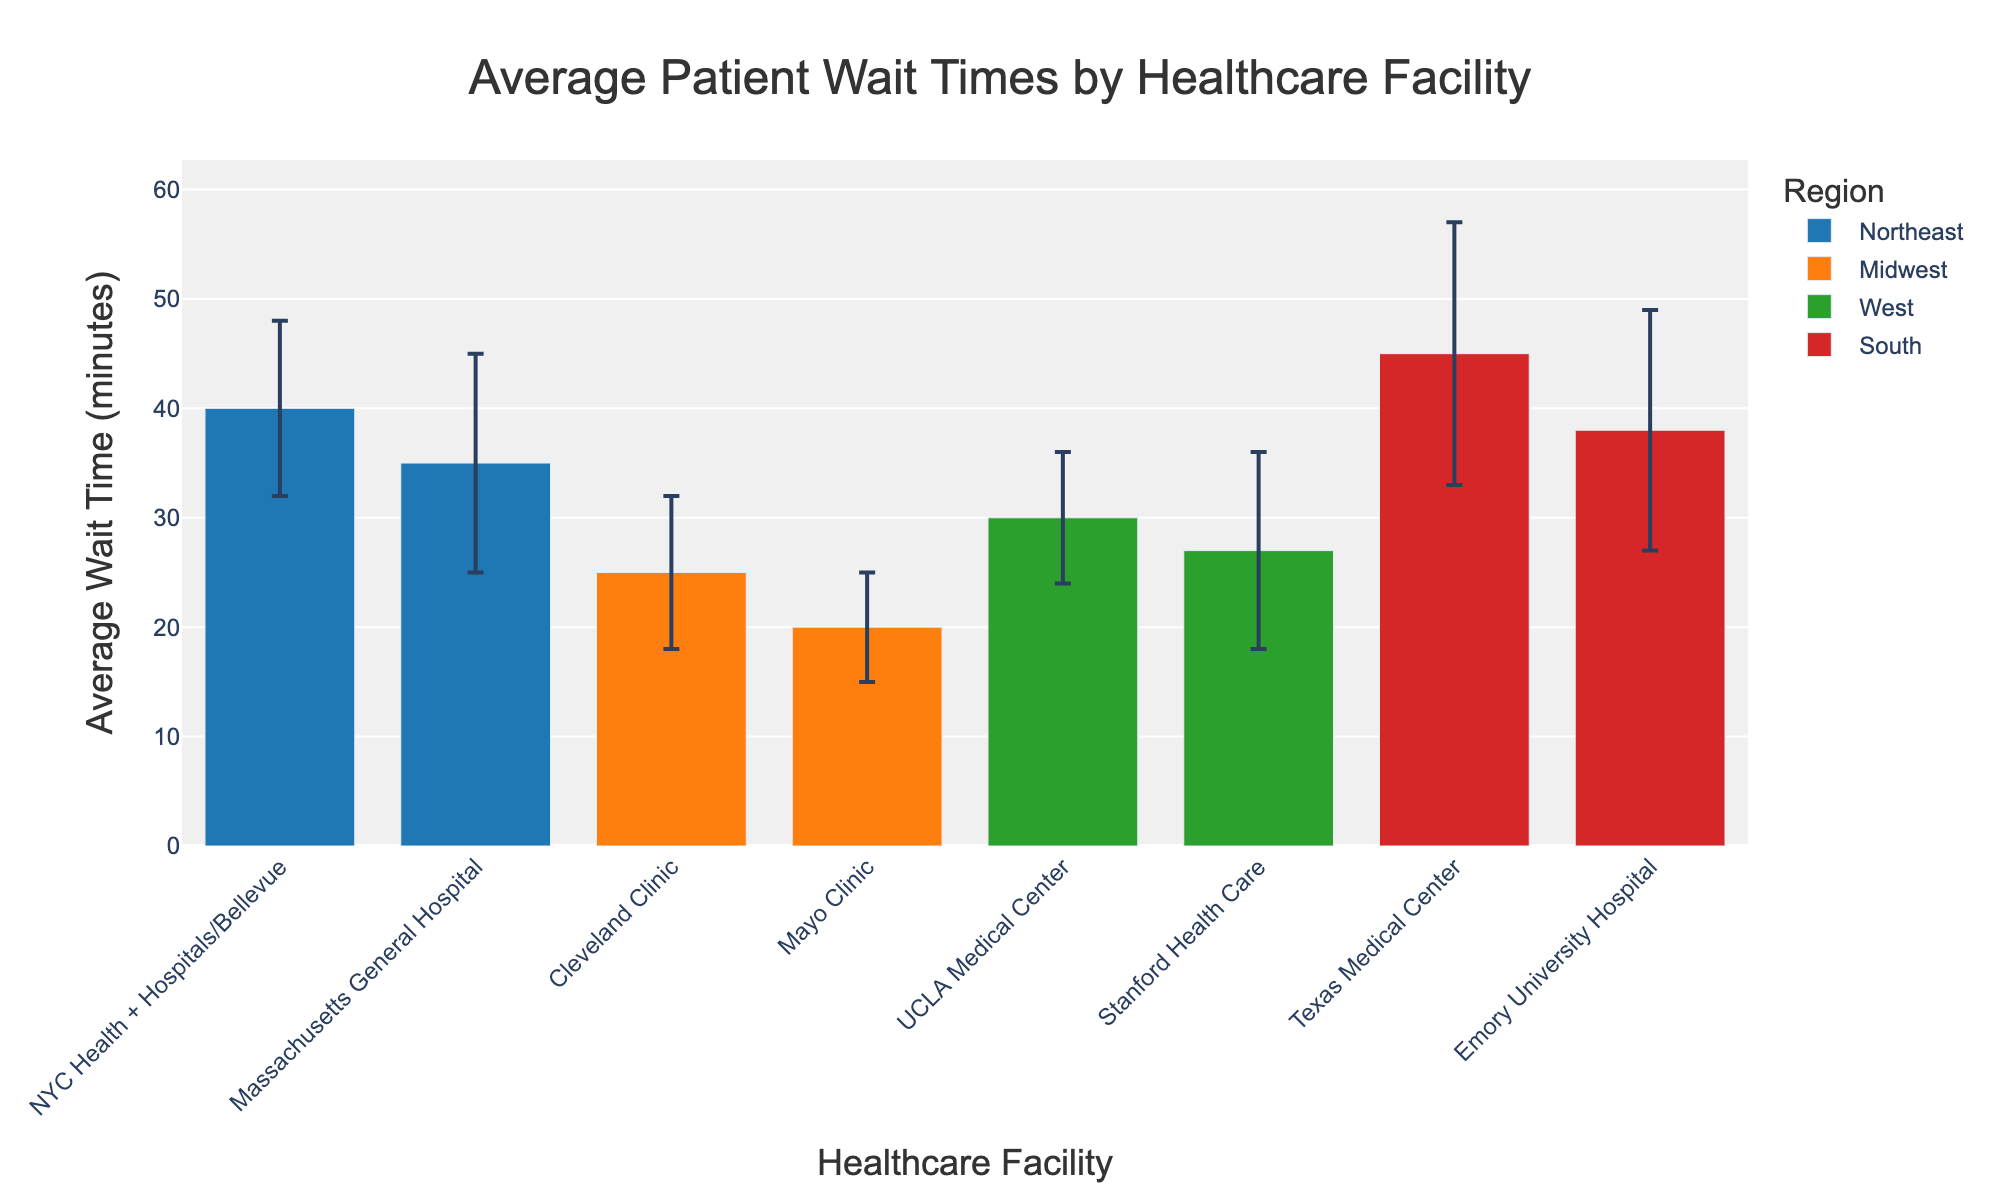What's the title of the bar chart? The title of the bar chart is located at the top of the figure. It provides a clear summary of what the chart is about. From the chart, the title is: 'Average Patient Wait Times by Healthcare Facility'
Answer: Average Patient Wait Times by Healthcare Facility Which region has the highest average patient wait time, and which healthcare facility is it? To answer this, look for the tallest bar in the chart and identify its region and healthcare facility. The Texas Medical Center in the South has the highest average wait time.
Answer: South, Texas Medical Center What is the average wait time at Mayo Clinic, and how much does it vary? Find the bar corresponding to Mayo Clinic and note its height for the average wait time and the length of the error bar for variation. The Mayo Clinic has an average wait time of 20 minutes with a standard deviation of 5 minutes.
Answer: 20 minutes, 5 minutes How do the wait times of NYC Health + Hospitals/Bellevue and Massachusetts General Hospital compare? Look at the bars for NYC Health + Hospitals/Bellevue and Massachusetts General Hospital. NYC Health + Hospitals/Bellevue has an average wait time of 40 minutes, whereas Massachusetts General Hospital has 35 minutes.
Answer: NYC Health + Hospitals/Bellevue has 40 minutes, Massachusetts General Hospital has 35 minutes What is the average patient wait time for healthcare facilities in the Northeast region? Add the average wait times for facilities in the Northeast and divide by the number of facilities. (40 + 35) / 2 = 75 / 2 = 37.5
Answer: 37.5 minutes Which region has the lowest overall patient wait times and which healthcare facility represents this? Identify the shortest bar among all regions. The Mayo Clinic in the Midwest has the lowest average wait time.
Answer: Midwest, Mayo Clinic How do the wait times at Cleveland Clinic and UCLA Medical Center compare, considering their respective standard deviations? Compare the average wait times and the lengths of the error bars. Cleveland Clinic's average wait time is 25 minutes with a 7-minute standard deviation, while UCLA Medical Center's average wait time is 30 minutes with a 6-minute standard deviation.
Answer: Cleveland Clinic: 25±7 minutes, UCLA Medical Center: 30±6 minutes How much longer is the average wait time at Texas Medical Center compared to Mayo Clinic? Subtract the average wait time of Mayo Clinic from that of Texas Medical Center, 45 - 20 = 25
Answer: 25 minutes Which healthcare facility in the West has the higher average patient wait time? Compare the bars for the facilities in the West region. UCLA Medical Center has a higher average wait time compared to Stanford Health Care.
Answer: UCLA Medical Center 